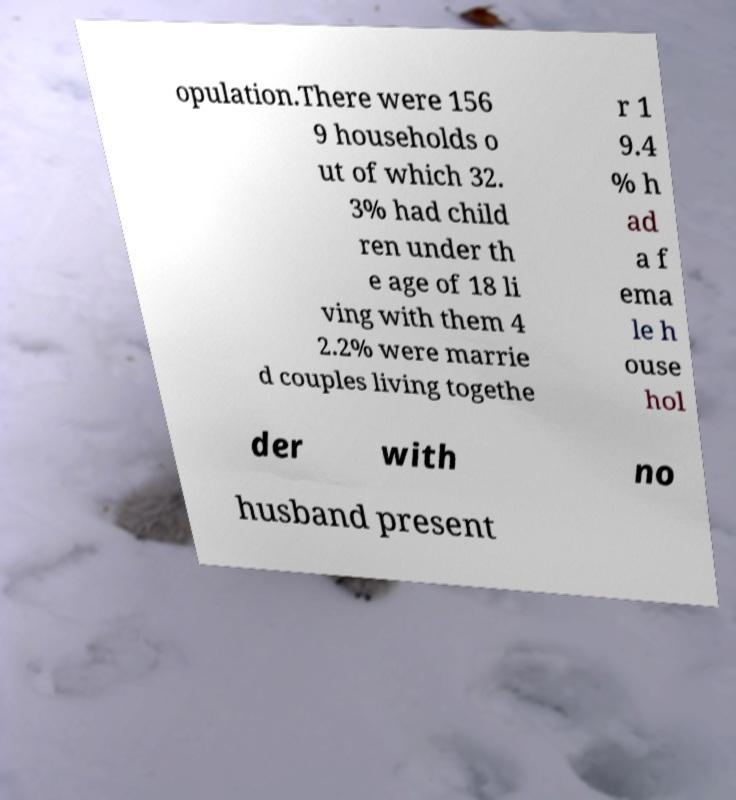Could you assist in decoding the text presented in this image and type it out clearly? opulation.There were 156 9 households o ut of which 32. 3% had child ren under th e age of 18 li ving with them 4 2.2% were marrie d couples living togethe r 1 9.4 % h ad a f ema le h ouse hol der with no husband present 